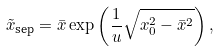<formula> <loc_0><loc_0><loc_500><loc_500>\tilde { x } _ { \text {sep} } = \bar { x } \exp \left ( \frac { 1 } { u } \sqrt { x _ { 0 } ^ { 2 } - \bar { x } ^ { 2 } } \right ) ,</formula> 